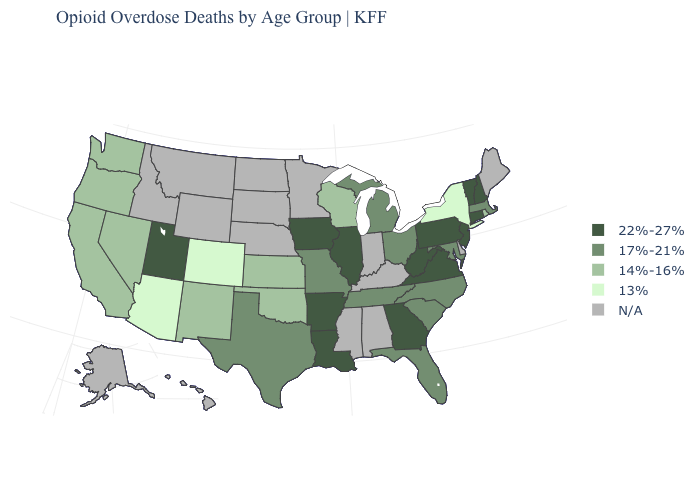What is the value of New York?
Concise answer only. 13%. Name the states that have a value in the range 14%-16%?
Be succinct. California, Kansas, Nevada, New Mexico, Oklahoma, Oregon, Rhode Island, Washington, Wisconsin. Name the states that have a value in the range 22%-27%?
Answer briefly. Arkansas, Connecticut, Georgia, Illinois, Iowa, Louisiana, New Hampshire, New Jersey, Pennsylvania, Utah, Vermont, Virginia, West Virginia. What is the value of Colorado?
Be succinct. 13%. Which states have the lowest value in the USA?
Answer briefly. Arizona, Colorado, New York. What is the lowest value in the MidWest?
Quick response, please. 14%-16%. What is the lowest value in the USA?
Be succinct. 13%. What is the value of Missouri?
Be succinct. 17%-21%. What is the value of North Dakota?
Concise answer only. N/A. What is the value of Utah?
Be succinct. 22%-27%. Among the states that border Louisiana , which have the lowest value?
Answer briefly. Texas. Name the states that have a value in the range 17%-21%?
Concise answer only. Florida, Maryland, Massachusetts, Michigan, Missouri, North Carolina, Ohio, South Carolina, Tennessee, Texas. What is the value of North Dakota?
Answer briefly. N/A. 